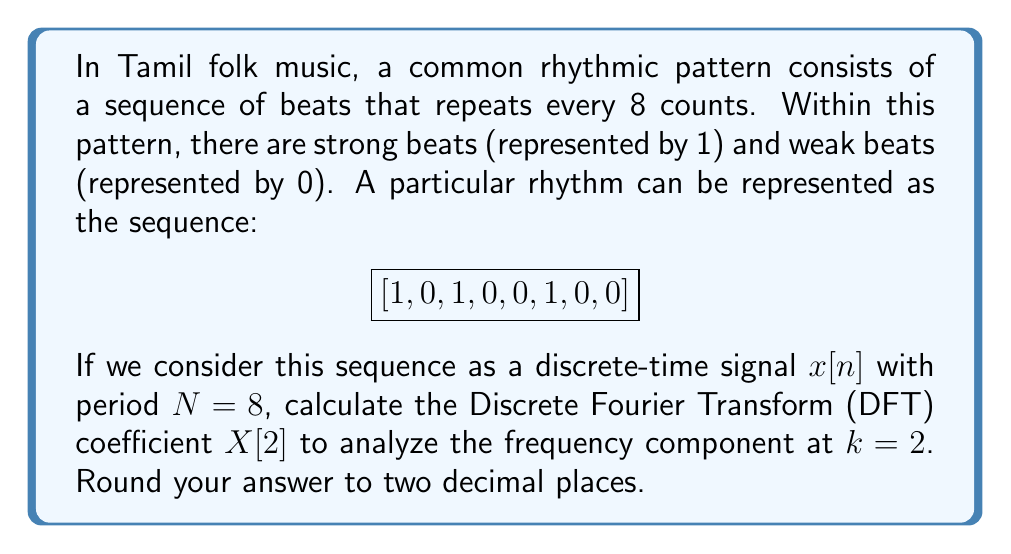Can you answer this question? To solve this problem, we'll follow these steps:

1) The Discrete Fourier Transform (DFT) for a sequence $x[n]$ of length $N$ is given by:

   $$X[k] = \sum_{n=0}^{N-1} x[n] e^{-j2\pi kn/N}$$

   where $k = 0, 1, ..., N-1$

2) In our case, $N = 8$ and we need to calculate $X[2]$. So, our formula becomes:

   $$X[2] = \sum_{n=0}^{7} x[n] e^{-j2\pi 2n/8}$$

3) Expand this sum:

   $$X[2] = x[0]e^{-j2\pi 2(0)/8} + x[1]e^{-j2\pi 2(1)/8} + ... + x[7]e^{-j2\pi 2(7)/8}$$

4) Simplify the exponents:

   $$X[2] = x[0]e^{0} + x[1]e^{-j\pi/2} + x[2]e^{-j\pi} + x[3]e^{-j3\pi/2} + x[4]e^{-j2\pi} + x[5]e^{-j5\pi/2} + x[6]e^{-j3\pi} + x[7]e^{-j7\pi/2}$$

5) Substitute the values of $x[n]$ and simplify:

   $$X[2] = 1(1) + 0(-j) + 1(-1) + 0(j) + 0(1) + 1(-j) + 0(-1) + 0(j)$$

6) Combine terms:

   $$X[2] = 1 - 1 - j$$

7) Express in complex form:

   $$X[2] = 0 - j$$

8) Convert to magnitude and phase form:

   Magnitude: $|X[2]| = \sqrt{0^2 + 1^2} = 1$
   Phase: $\angle X[2] = \tan^{-1}(-\infty) = -\pi/2 = -1.57$ radians
Answer: $1 \angle -1.57$ radians 